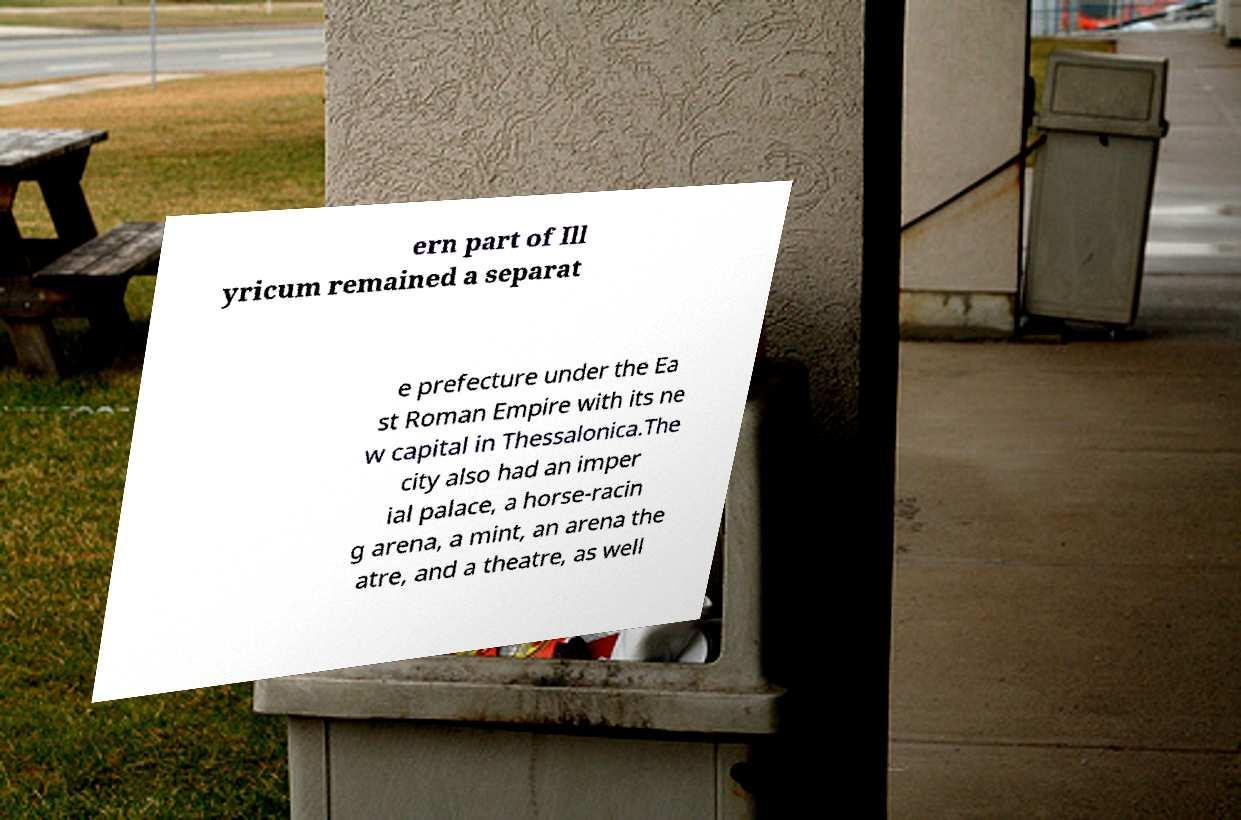Please read and relay the text visible in this image. What does it say? ern part of Ill yricum remained a separat e prefecture under the Ea st Roman Empire with its ne w capital in Thessalonica.The city also had an imper ial palace, a horse-racin g arena, a mint, an arena the atre, and a theatre, as well 